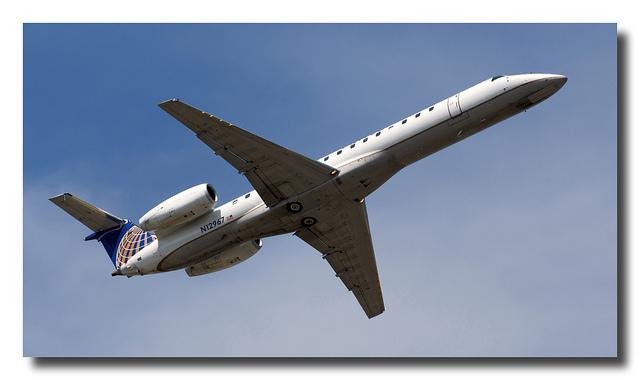What is the nomenclature depicted on the wing?
Keep it brief. N12967. How many windows do you see?
Answer briefly. 12. Is there a bus in the background?
Write a very short answer. No. Could that plane fly for Continental?
Quick response, please. Yes. 